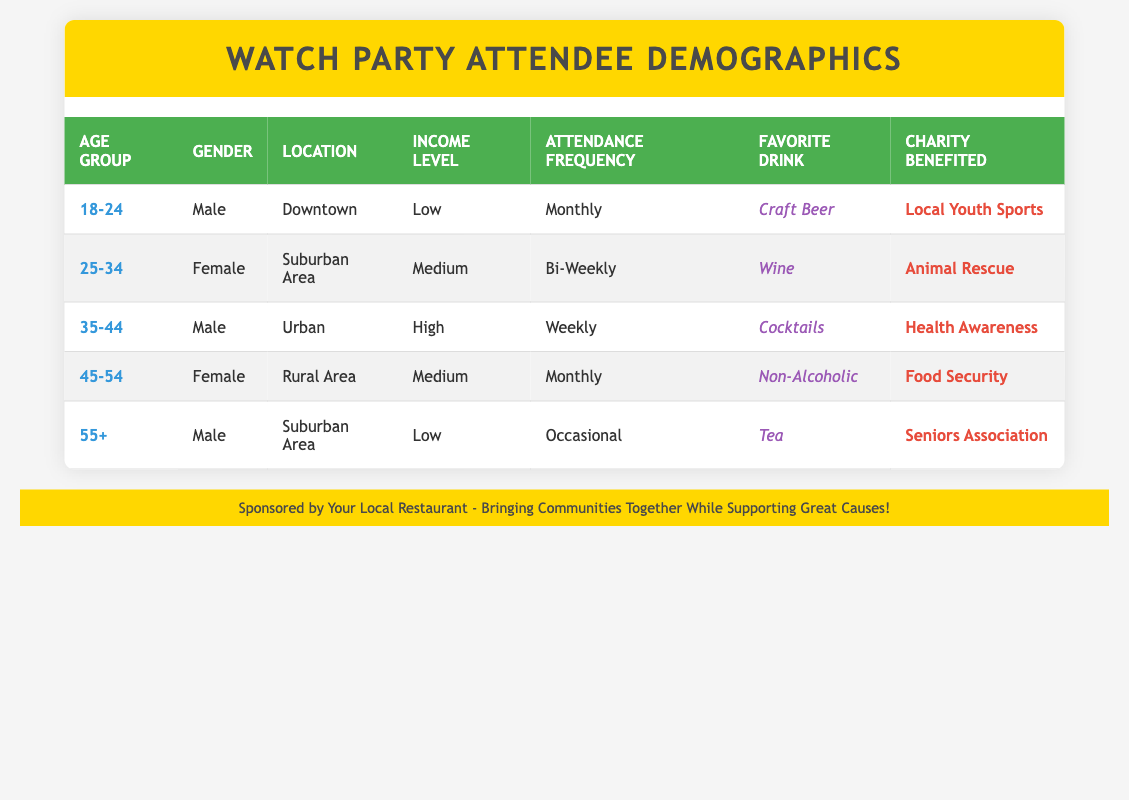What is the favorite drink of the 18-24 age group? The table lists that the favorite drink of the 18-24 age group is "Craft Beer." This is stated directly in the row corresponding to this age group.
Answer: Craft Beer How many attendees have a high income level? In the table, there is only one attendee listed with a high income level, which corresponds to the 35-44 age group. This can be found in the relevant row under the "Income Level" column.
Answer: 1 Do any female attendees prefer tea as their favorite drink? The table shows that the only attendee who prefers tea is a male in the 55+ age group. No females are listed with tea as their favorite drink, indicating that the statement is false.
Answer: No Which charity is supported by the attendee in the 45-54 age group? The table indicates that the charity benefited by the attendee in the 45-54 age group is "Food Security." This information is found in the respective row under the "Charity Benefited" column.
Answer: Food Security What is the average attendance frequency for all attendees? The frequencies are Monthly (twice), Bi-Weekly, Weekly, and Occasional. We can assign numerical values: Monthly = 2, Bi-Weekly = 2, Weekly = 1, Occasional = 0. Average = (2 + 2 + 1 + 2 + 0)/5 = 1.4, which is approximately between Monthly and Bi-Weekly.
Answer: 1.4 Is there a male attendee from Urban who attends weekly? The table confirms that there is indeed a male attendee from the Urban area who attends weekly, specifically, this is the 35-44 age group. Thus, the statement is true.
Answer: Yes What percentage of attendees are from Suburban areas? There are two attendees from Suburban areas out of five total attendees. Calculating the percentage: (2/5) * 100 = 40%. Hence, 40% of attendees are from Suburban areas.
Answer: 40% Which age group has the highest number of attendees in the table? Each age group has only one attendee listed, thus there is no age group with a higher number than one. This makes the highest count equal across all age groups.
Answer: All age groups are equal 